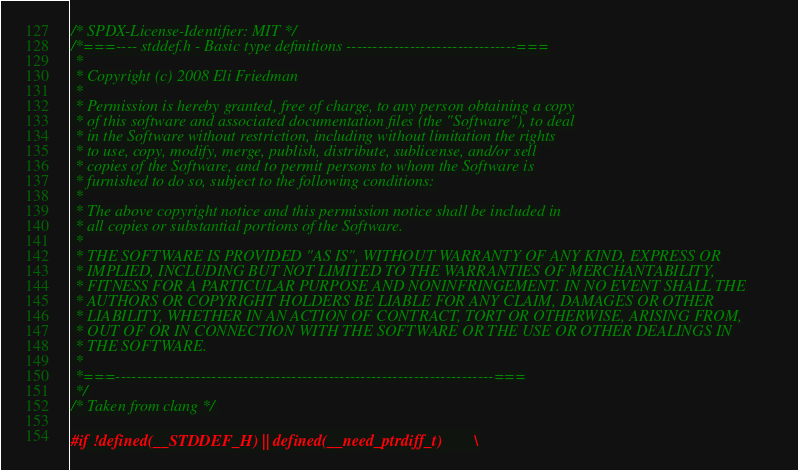<code> <loc_0><loc_0><loc_500><loc_500><_C_>/* SPDX-License-Identifier: MIT */
/*===---- stddef.h - Basic type definitions --------------------------------===
 *
 * Copyright (c) 2008 Eli Friedman
 *
 * Permission is hereby granted, free of charge, to any person obtaining a copy
 * of this software and associated documentation files (the "Software"), to deal
 * in the Software without restriction, including without limitation the rights
 * to use, copy, modify, merge, publish, distribute, sublicense, and/or sell
 * copies of the Software, and to permit persons to whom the Software is
 * furnished to do so, subject to the following conditions:
 *
 * The above copyright notice and this permission notice shall be included in
 * all copies or substantial portions of the Software.
 *
 * THE SOFTWARE IS PROVIDED "AS IS", WITHOUT WARRANTY OF ANY KIND, EXPRESS OR
 * IMPLIED, INCLUDING BUT NOT LIMITED TO THE WARRANTIES OF MERCHANTABILITY,
 * FITNESS FOR A PARTICULAR PURPOSE AND NONINFRINGEMENT. IN NO EVENT SHALL THE
 * AUTHORS OR COPYRIGHT HOLDERS BE LIABLE FOR ANY CLAIM, DAMAGES OR OTHER
 * LIABILITY, WHETHER IN AN ACTION OF CONTRACT, TORT OR OTHERWISE, ARISING FROM,
 * OUT OF OR IN CONNECTION WITH THE SOFTWARE OR THE USE OR OTHER DEALINGS IN
 * THE SOFTWARE.
 *
 *===-----------------------------------------------------------------------===
 */
/* Taken from clang */

#if !defined(__STDDEF_H) || defined(__need_ptrdiff_t)		\</code> 